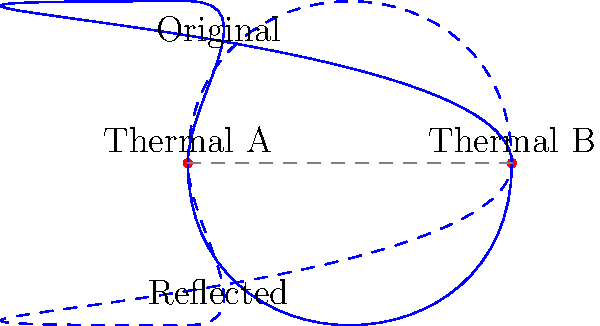A glider performs a figure-eight pattern around two thermal columns, A and B. If the glider's trajectory is reflected across the line connecting the two thermal columns, what transformation would accurately describe this reflection? To understand the transformation of the glider's trajectory, let's follow these steps:

1. The original trajectory forms a figure-eight pattern around two thermal columns, A and B.

2. The line connecting thermal columns A and B serves as the axis of reflection.

3. The reflection transformation can be described mathematically as a linear transformation that maps each point $(x, y)$ to a point $(x', y')$ such that:
   
   a) The line connecting $(x, y)$ and $(x', y')$ is perpendicular to the axis of reflection.
   b) The distance from $(x, y)$ to the axis equals the distance from $(x', y')$ to the axis.

4. In geometry, this transformation is known as an axial reflection or a reflection across a line.

5. The properties of this reflection include:
   
   a) It preserves the shape and size of the original figure (isometry).
   b) It reverses the orientation of the figure.
   c) Points on the axis of reflection remain fixed.

6. In this case, the entire figure-eight pattern is reflected across the line AB, creating a mirror image of the original trajectory.

7. The resulting reflected path forms an inverted figure-eight pattern, which is congruent to the original but with opposite orientation.

Therefore, the transformation that accurately describes this reflection is an axial reflection (or line reflection) across the line connecting thermal columns A and B.
Answer: Axial reflection across line AB 